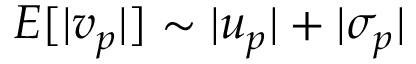<formula> <loc_0><loc_0><loc_500><loc_500>E [ | v _ { p } | ] \sim | u _ { p } | + | \sigma _ { p } |</formula> 